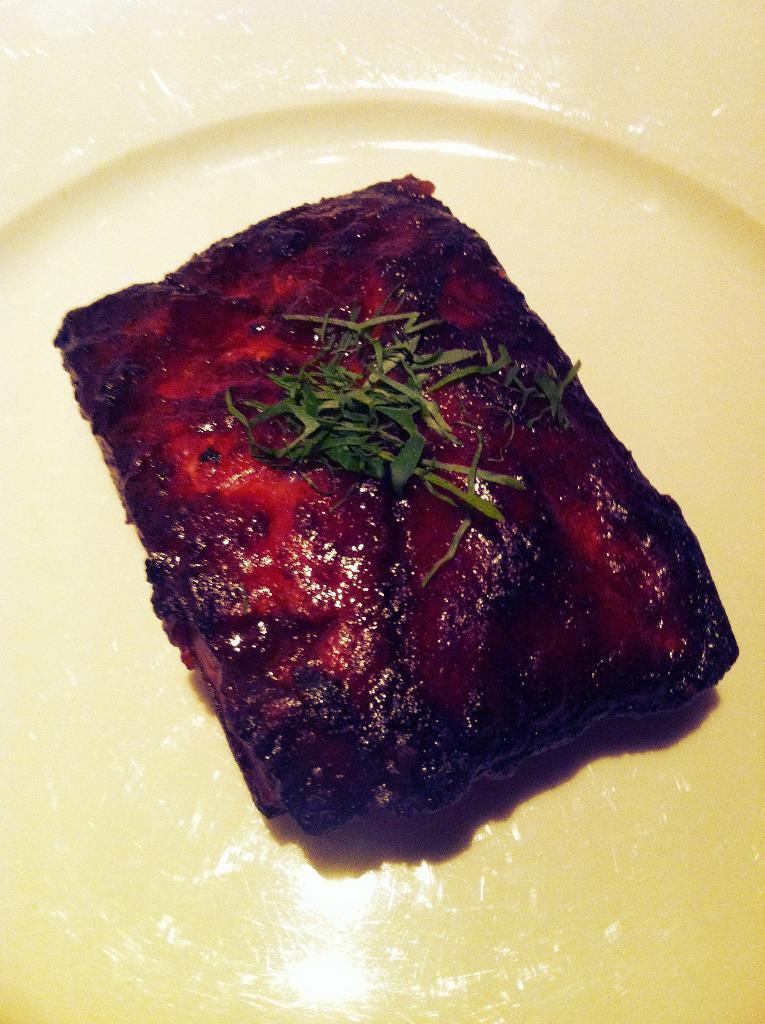Describe this image in one or two sentences. This is a zoomed in picture. In the foreground we can see a platter containing some food items. 